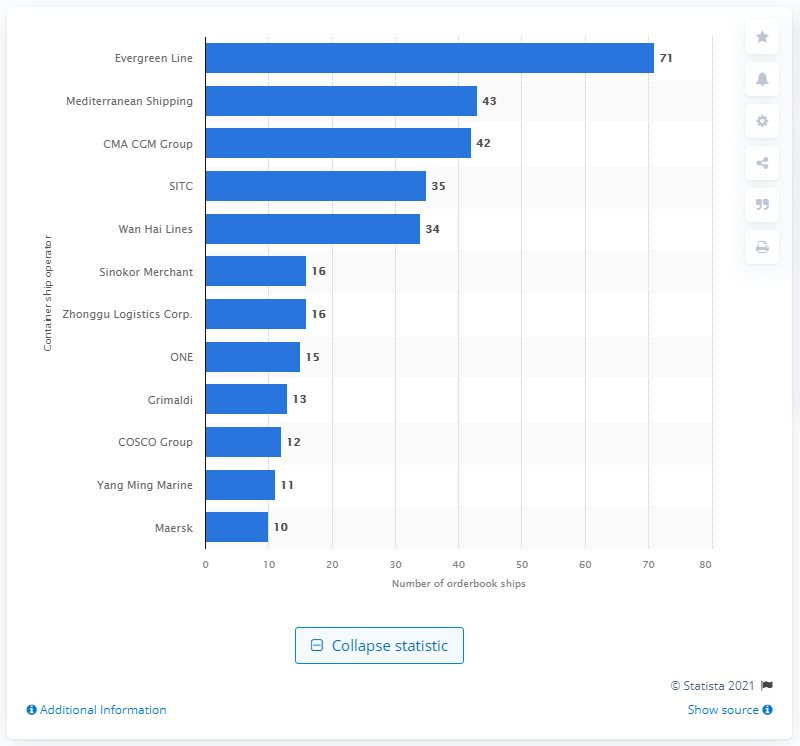How many ships were in CMA CGM Group's order book as of June 21, 2021? As of June 21, 2021, the CMA CGM Group had 42 ships listed in their order book. This number highlights the company's significant expansion plans and positions them prominently among global shipping operators. 